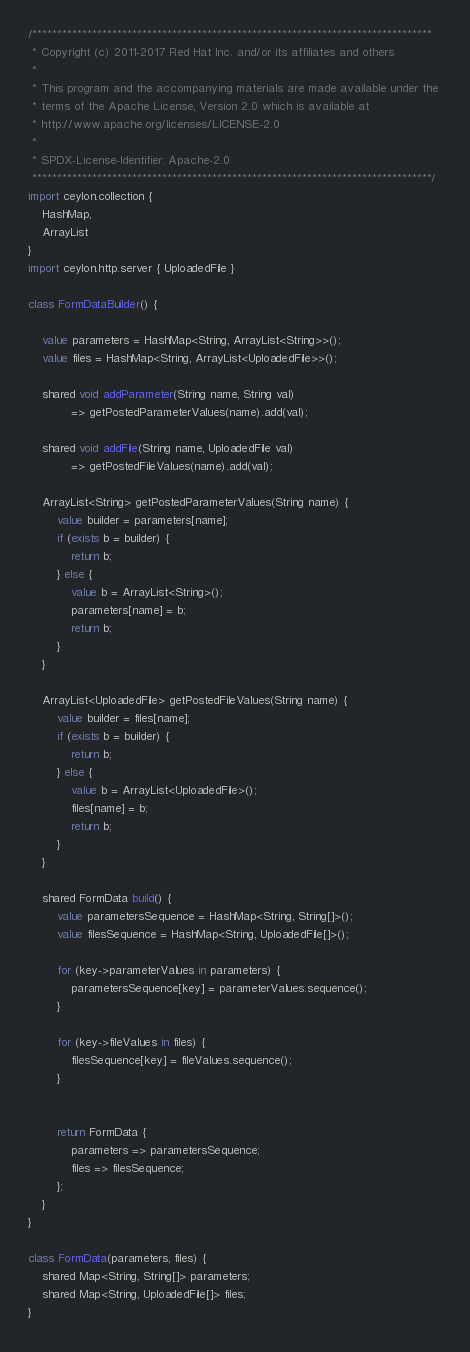<code> <loc_0><loc_0><loc_500><loc_500><_Ceylon_>/********************************************************************************
 * Copyright (c) 2011-2017 Red Hat Inc. and/or its affiliates and others
 *
 * This program and the accompanying materials are made available under the 
 * terms of the Apache License, Version 2.0 which is available at
 * http://www.apache.org/licenses/LICENSE-2.0
 *
 * SPDX-License-Identifier: Apache-2.0 
 ********************************************************************************/
import ceylon.collection { 
    HashMap,
    ArrayList
}
import ceylon.http.server { UploadedFile }

class FormDataBuilder() {
    
    value parameters = HashMap<String, ArrayList<String>>();
    value files = HashMap<String, ArrayList<UploadedFile>>();
    
    shared void addParameter(String name, String val) 
            => getPostedParameterValues(name).add(val);
    
    shared void addFile(String name, UploadedFile val) 
            => getPostedFileValues(name).add(val);
    
    ArrayList<String> getPostedParameterValues(String name) {
        value builder = parameters[name];
        if (exists b = builder) {
            return b;
        } else {
            value b = ArrayList<String>();
            parameters[name] = b;
            return b;
        }
    }
    
    ArrayList<UploadedFile> getPostedFileValues(String name) {
        value builder = files[name];
        if (exists b = builder) {
            return b;
        } else {
            value b = ArrayList<UploadedFile>();
            files[name] = b;
            return b;
        }
    }
    
    shared FormData build() {
        value parametersSequence = HashMap<String, String[]>();
        value filesSequence = HashMap<String, UploadedFile[]>();
        
        for (key->parameterValues in parameters) {
            parametersSequence[key] = parameterValues.sequence();
        }
        
        for (key->fileValues in files) {
            filesSequence[key] = fileValues.sequence();
        }
        
        
        return FormData { 
            parameters => parametersSequence; 
            files => filesSequence; 
        };
    }
}

class FormData(parameters, files) {
    shared Map<String, String[]> parameters;
    shared Map<String, UploadedFile[]> files;
}</code> 